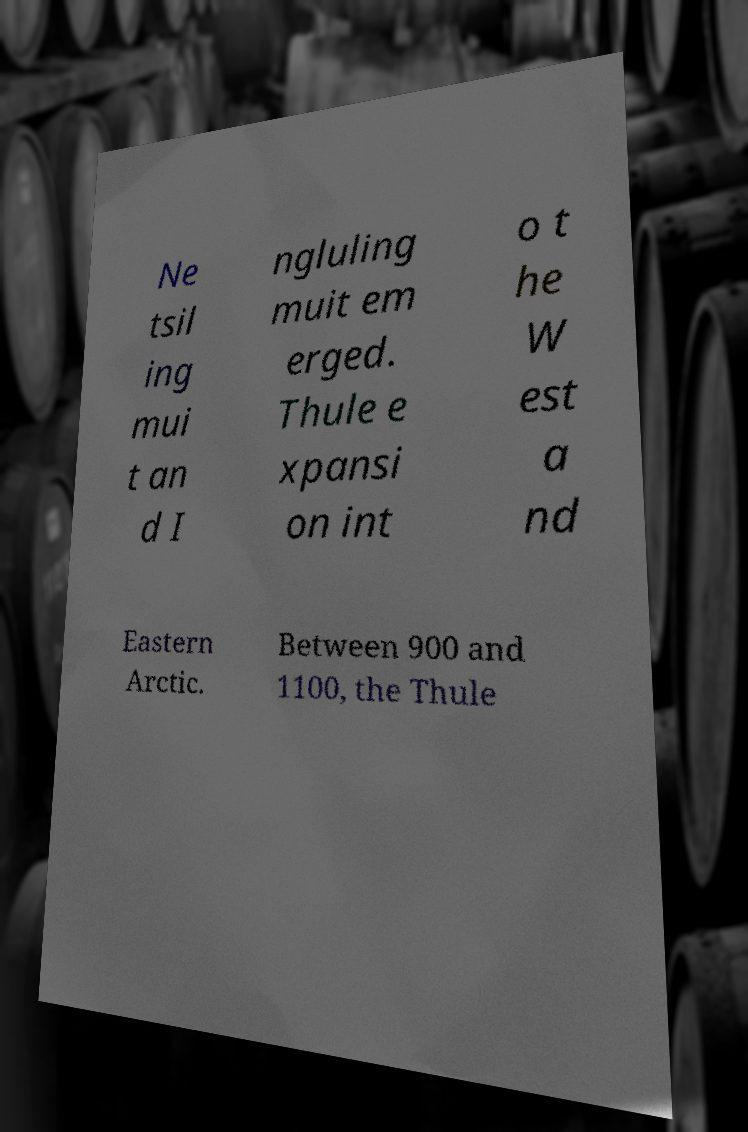For documentation purposes, I need the text within this image transcribed. Could you provide that? Ne tsil ing mui t an d I ngluling muit em erged. Thule e xpansi on int o t he W est a nd Eastern Arctic. Between 900 and 1100, the Thule 